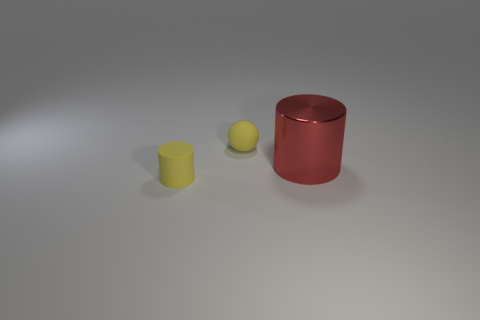Add 2 big blue things. How many objects exist? 5 Subtract all balls. How many objects are left? 2 Subtract 0 gray spheres. How many objects are left? 3 Subtract all red rubber cylinders. Subtract all yellow cylinders. How many objects are left? 2 Add 2 large red objects. How many large red objects are left? 3 Add 3 large gray shiny balls. How many large gray shiny balls exist? 3 